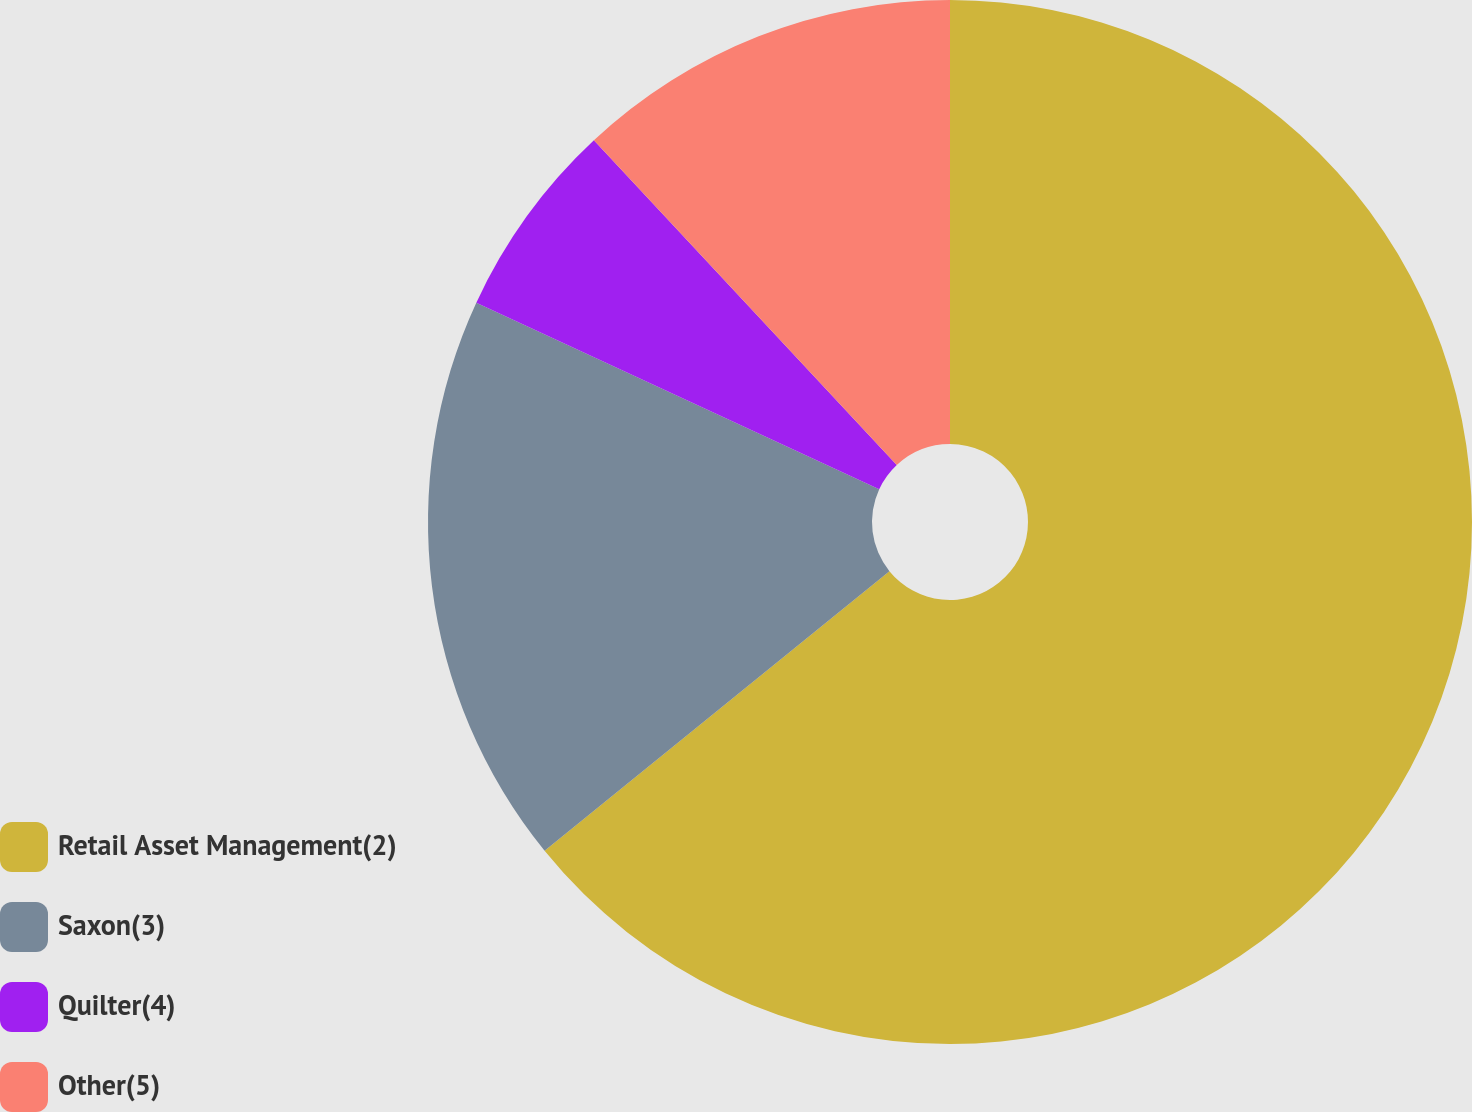<chart> <loc_0><loc_0><loc_500><loc_500><pie_chart><fcel>Retail Asset Management(2)<fcel>Saxon(3)<fcel>Quilter(4)<fcel>Other(5)<nl><fcel>64.16%<fcel>17.75%<fcel>6.15%<fcel>11.95%<nl></chart> 